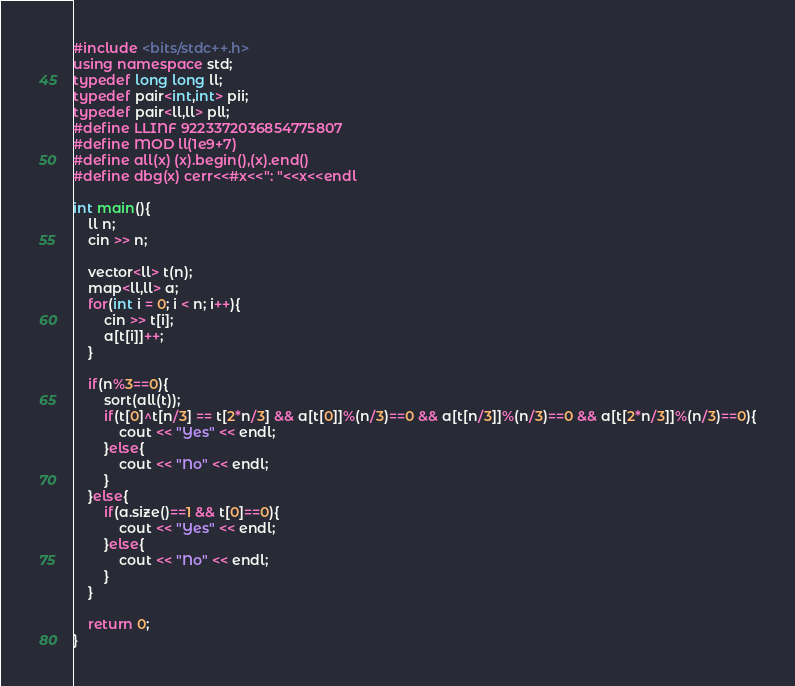Convert code to text. <code><loc_0><loc_0><loc_500><loc_500><_C++_>#include <bits/stdc++.h>
using namespace std;
typedef long long ll;
typedef pair<int,int> pii;
typedef pair<ll,ll> pll;
#define LLINF 9223372036854775807
#define MOD ll(1e9+7)
#define all(x) (x).begin(),(x).end()
#define dbg(x) cerr<<#x<<": "<<x<<endl

int main(){
    ll n;
    cin >> n;

    vector<ll> t(n);
    map<ll,ll> a;
    for(int i = 0; i < n; i++){
        cin >> t[i];
        a[t[i]]++;
    }

    if(n%3==0){
        sort(all(t));
        if(t[0]^t[n/3] == t[2*n/3] && a[t[0]]%(n/3)==0 && a[t[n/3]]%(n/3)==0 && a[t[2*n/3]]%(n/3)==0){
            cout << "Yes" << endl;
        }else{
            cout << "No" << endl;
        }
    }else{
        if(a.size()==1 && t[0]==0){
            cout << "Yes" << endl;
        }else{
            cout << "No" << endl;
        }
    }

    return 0;
}
</code> 